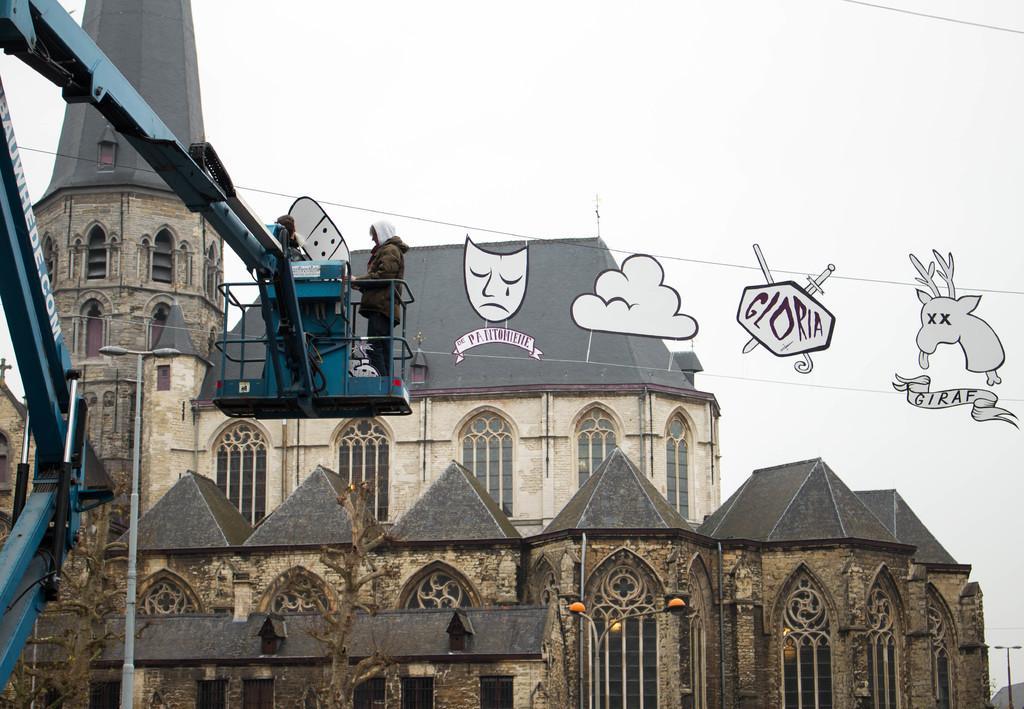How would you summarize this image in a sentence or two? In the center of the image there is a building. There are people standing in crane. 